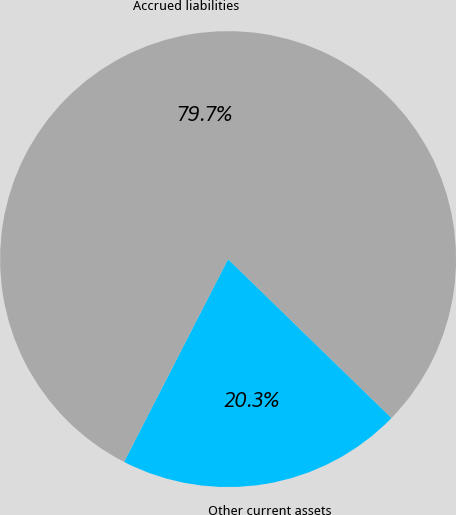Convert chart. <chart><loc_0><loc_0><loc_500><loc_500><pie_chart><fcel>Other current assets<fcel>Accrued liabilities<nl><fcel>20.27%<fcel>79.73%<nl></chart> 